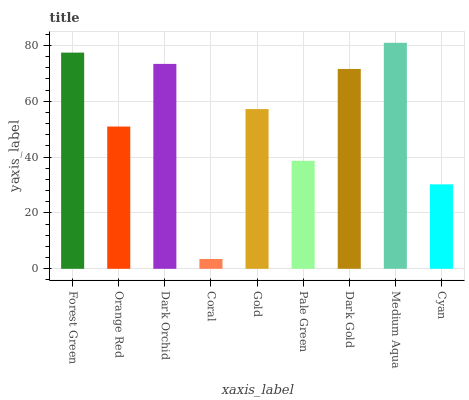Is Coral the minimum?
Answer yes or no. Yes. Is Medium Aqua the maximum?
Answer yes or no. Yes. Is Orange Red the minimum?
Answer yes or no. No. Is Orange Red the maximum?
Answer yes or no. No. Is Forest Green greater than Orange Red?
Answer yes or no. Yes. Is Orange Red less than Forest Green?
Answer yes or no. Yes. Is Orange Red greater than Forest Green?
Answer yes or no. No. Is Forest Green less than Orange Red?
Answer yes or no. No. Is Gold the high median?
Answer yes or no. Yes. Is Gold the low median?
Answer yes or no. Yes. Is Orange Red the high median?
Answer yes or no. No. Is Medium Aqua the low median?
Answer yes or no. No. 